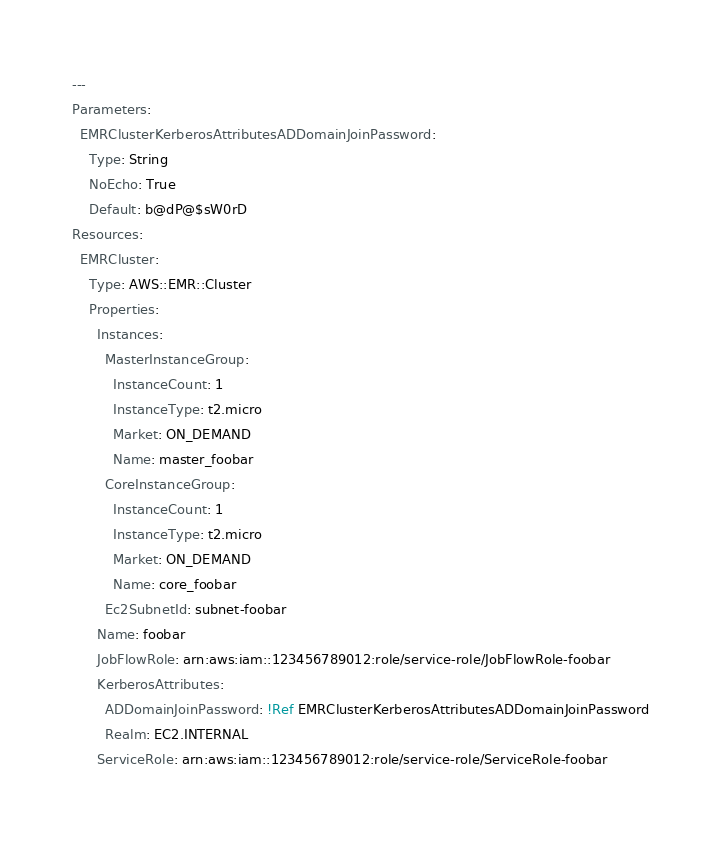<code> <loc_0><loc_0><loc_500><loc_500><_YAML_>---
Parameters:
  EMRClusterKerberosAttributesADDomainJoinPassword:
    Type: String
    NoEcho: True
    Default: b@dP@$sW0rD
Resources:
  EMRCluster:
    Type: AWS::EMR::Cluster
    Properties:
      Instances:
        MasterInstanceGroup:
          InstanceCount: 1
          InstanceType: t2.micro
          Market: ON_DEMAND
          Name: master_foobar
        CoreInstanceGroup:
          InstanceCount: 1
          InstanceType: t2.micro
          Market: ON_DEMAND
          Name: core_foobar
        Ec2SubnetId: subnet-foobar
      Name: foobar
      JobFlowRole: arn:aws:iam::123456789012:role/service-role/JobFlowRole-foobar
      KerberosAttributes:
        ADDomainJoinPassword: !Ref EMRClusterKerberosAttributesADDomainJoinPassword
        Realm: EC2.INTERNAL
      ServiceRole: arn:aws:iam::123456789012:role/service-role/ServiceRole-foobar
</code> 